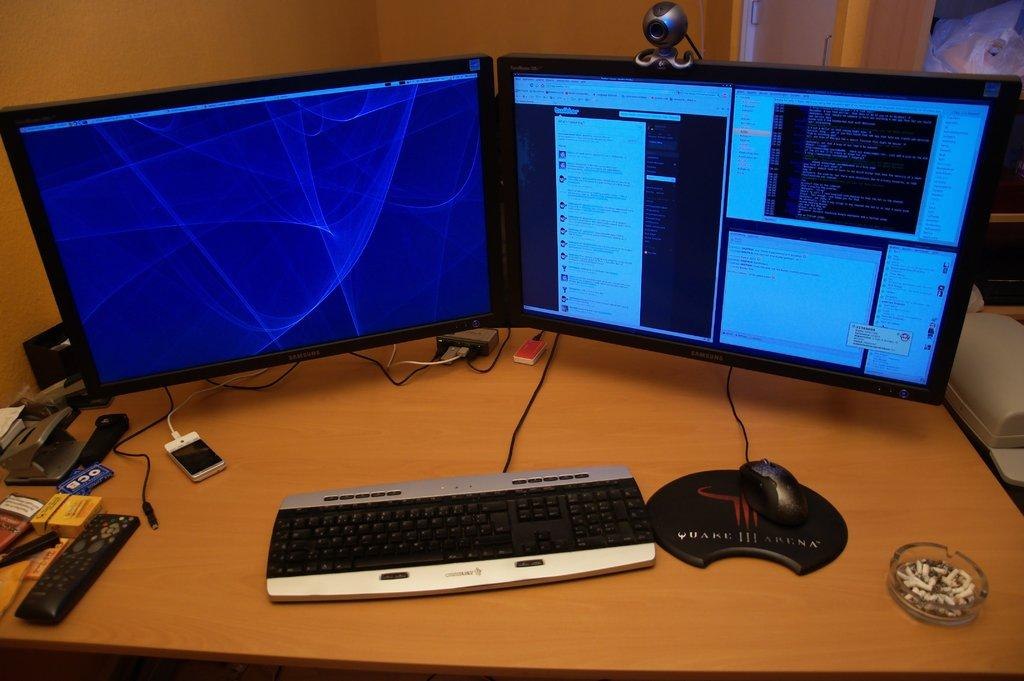<image>
Render a clear and concise summary of the photo. Two computer monitors on top of a desk a keyboard and a mouse on top of a Quake III Arena pad. 